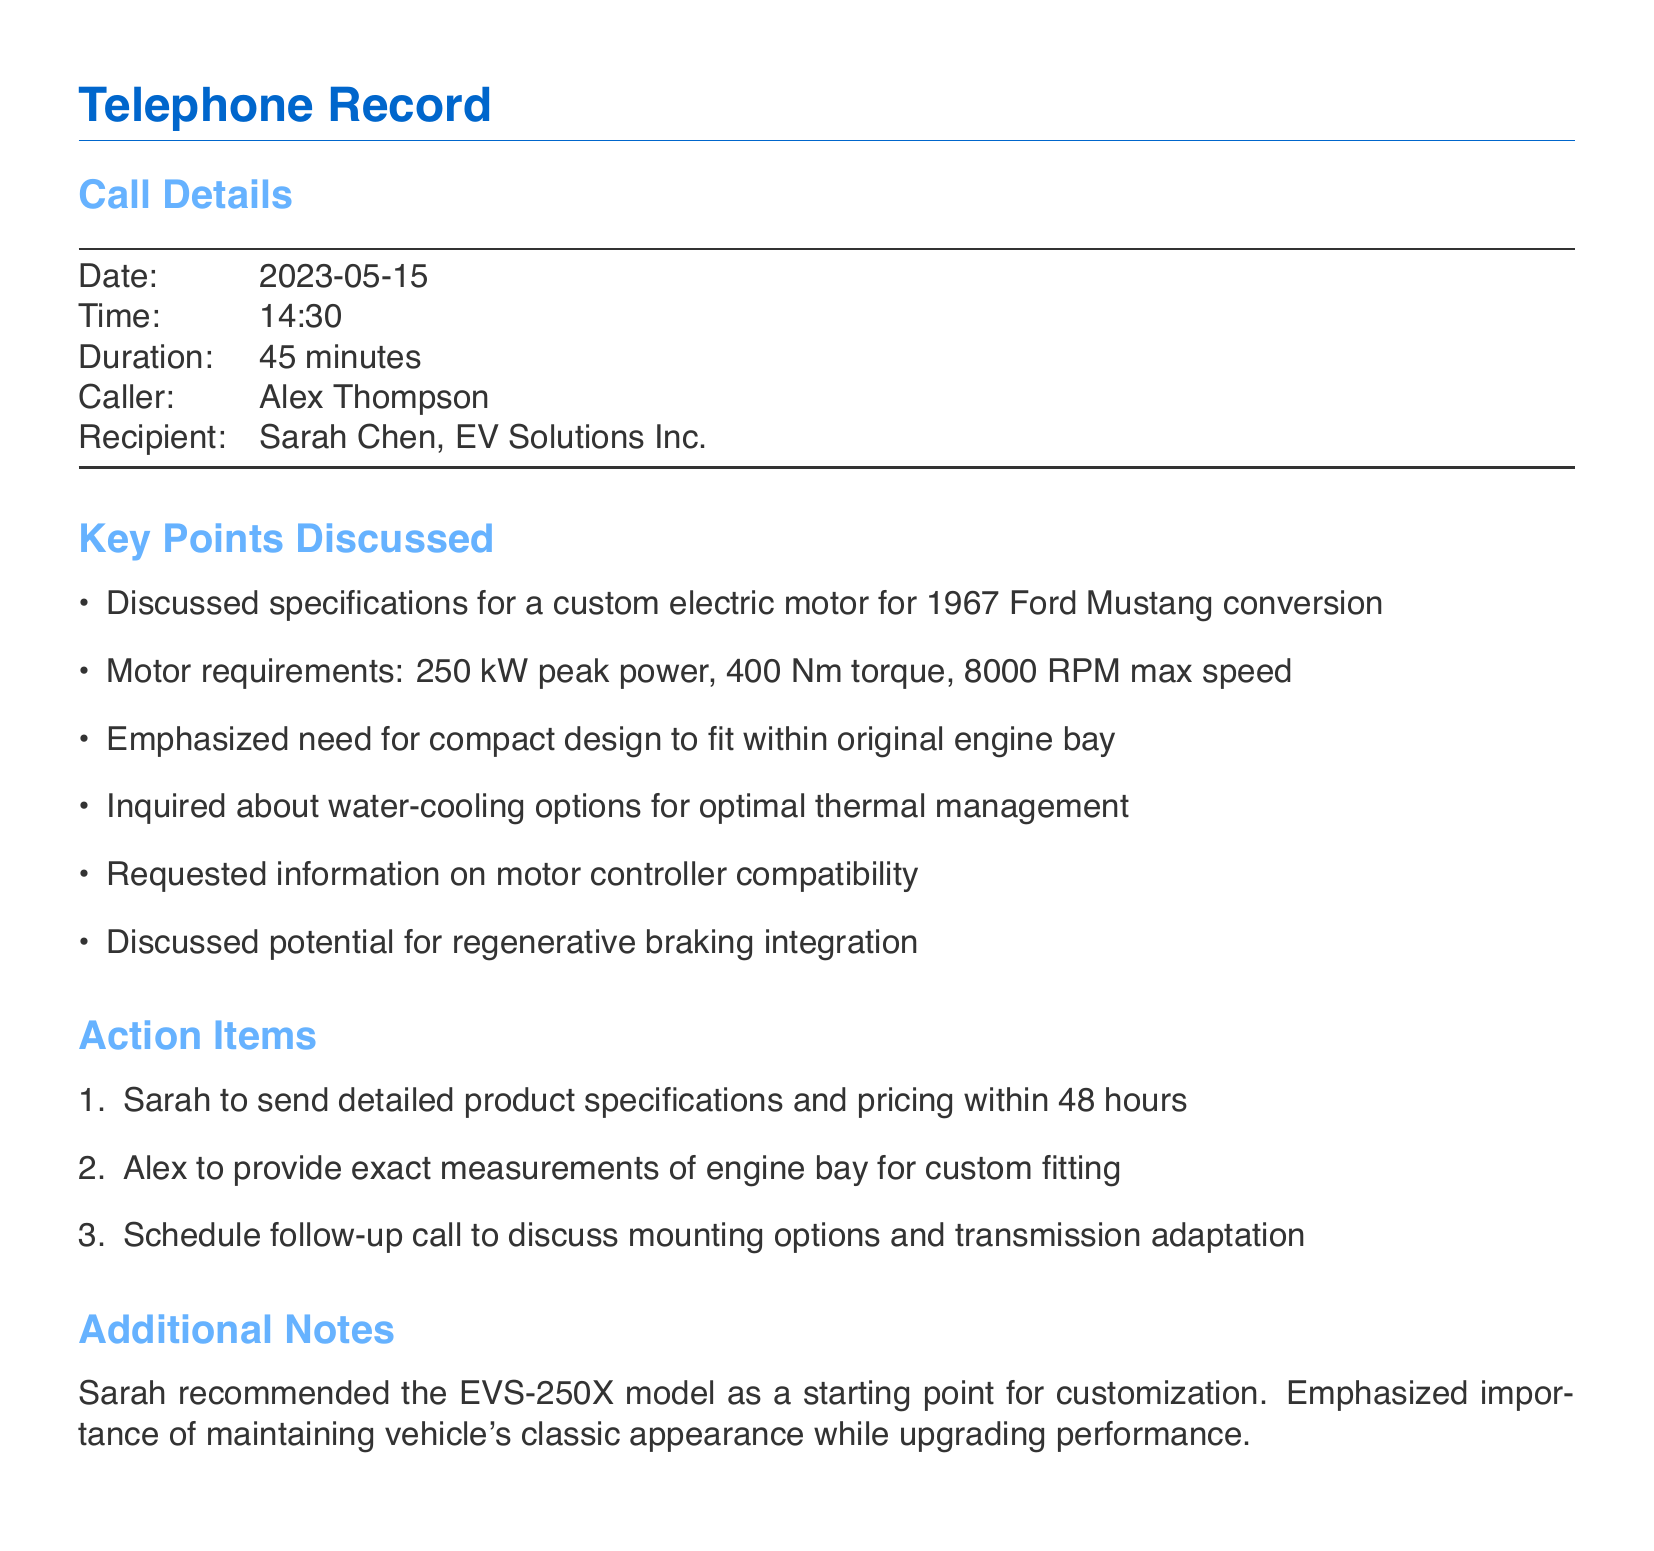What is the date of the call? The date of the call is stated in the call details section of the document.
Answer: 2023-05-15 Who was the caller? The caller's name is provided in the call details of the document.
Answer: Alex Thompson What is the peak power requirement of the electric motor? The peak power requirement is mentioned under the motor requirements in the key points discussed.
Answer: 250 kW What is the maximum speed of the motor? The maximum speed is specified in the motor requirements discussed during the call.
Answer: 8000 RPM Which model did Sarah recommend for customization? The model recommendation can be found in the additional notes section of the document.
Answer: EVS-250X How long did the call last? The duration of the call is detailed in the call details section.
Answer: 45 minutes What is one of the action items for Sarah? Action items are listed, and one pertains to what Sarah needs to send.
Answer: Send detailed product specifications and pricing What was emphasized about the vehicle's appearance? This emphasis is noted in the additional notes section regarding the vehicle's upgrade.
Answer: Maintaining classic appearance What does Alex need to provide for custom fitting? This requirement is mentioned under the action items for Alex in the document.
Answer: Exact measurements of engine bay 